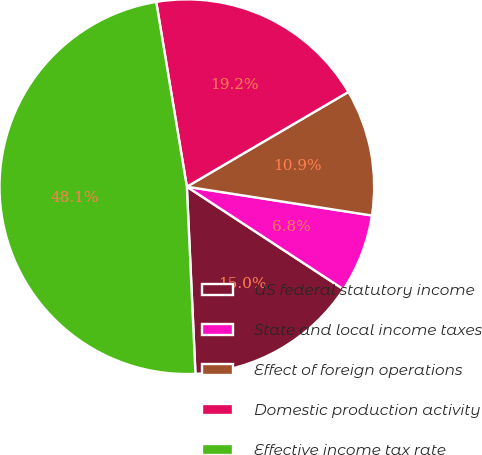Convert chart to OTSL. <chart><loc_0><loc_0><loc_500><loc_500><pie_chart><fcel>US federal statutory income<fcel>State and local income taxes<fcel>Effect of foreign operations<fcel>Domestic production activity<fcel>Effective income tax rate<nl><fcel>15.04%<fcel>6.77%<fcel>10.9%<fcel>19.17%<fcel>48.12%<nl></chart> 